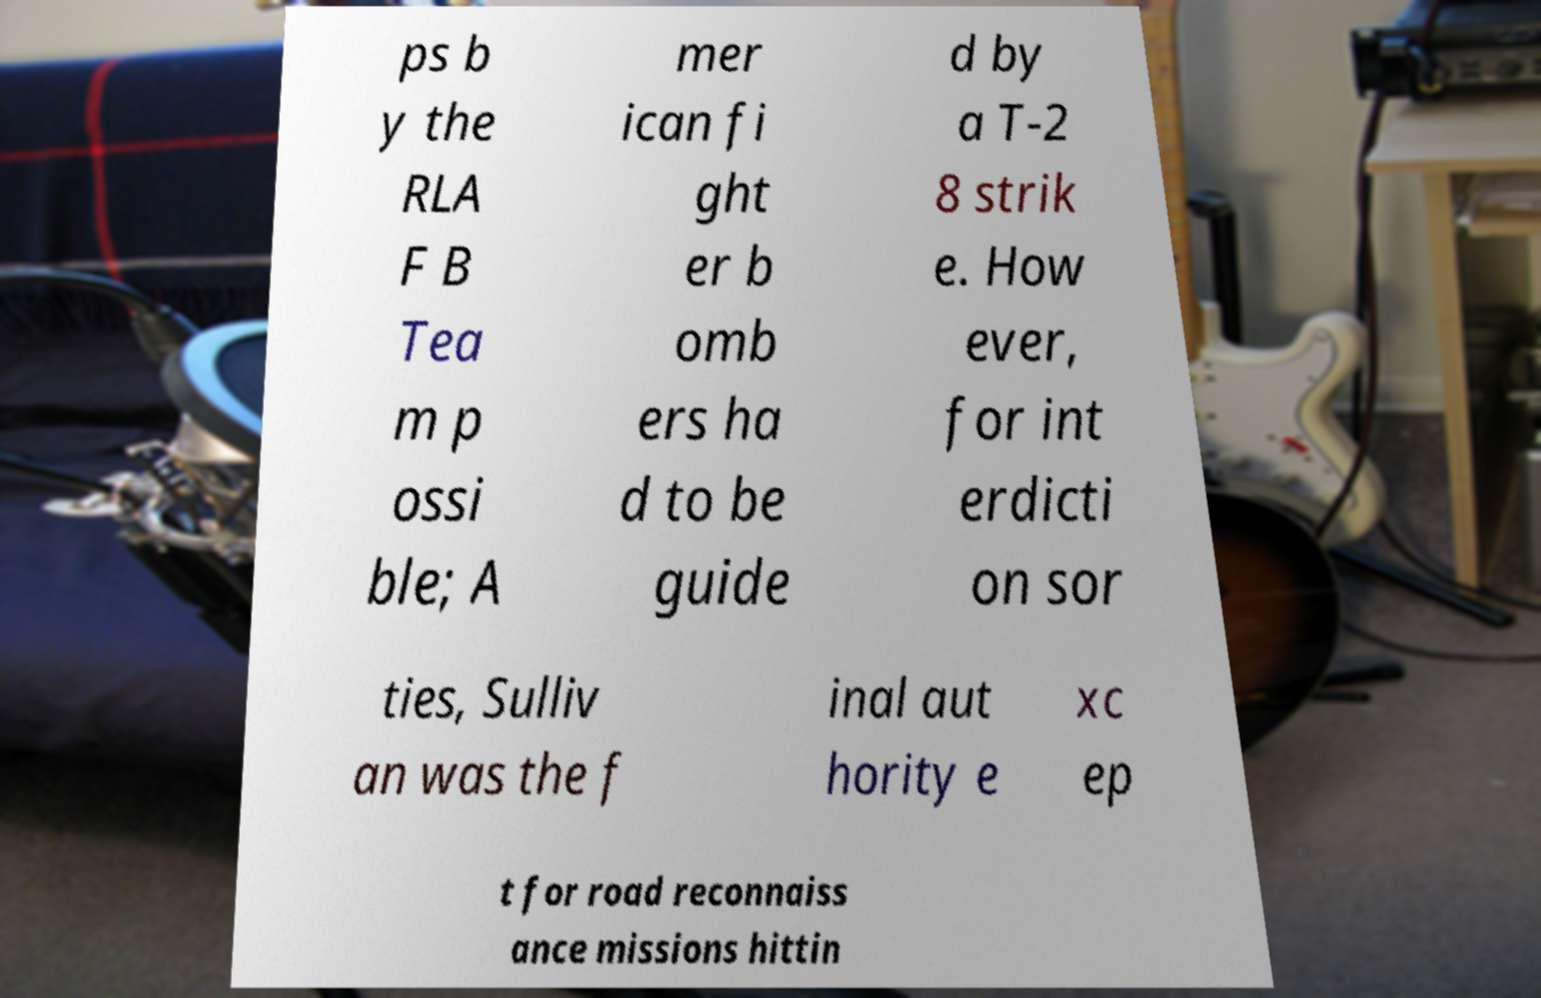Please identify and transcribe the text found in this image. ps b y the RLA F B Tea m p ossi ble; A mer ican fi ght er b omb ers ha d to be guide d by a T-2 8 strik e. How ever, for int erdicti on sor ties, Sulliv an was the f inal aut hority e xc ep t for road reconnaiss ance missions hittin 